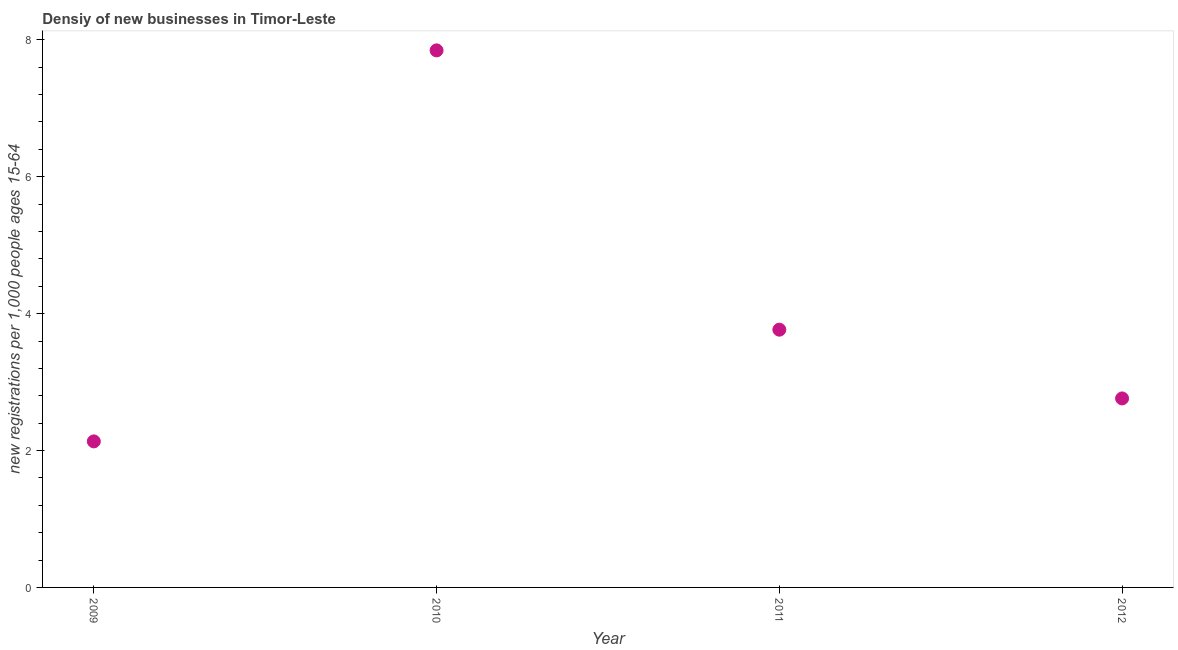What is the density of new business in 2012?
Offer a terse response. 2.76. Across all years, what is the maximum density of new business?
Offer a terse response. 7.85. Across all years, what is the minimum density of new business?
Keep it short and to the point. 2.13. In which year was the density of new business minimum?
Your answer should be very brief. 2009. What is the sum of the density of new business?
Your answer should be compact. 16.51. What is the difference between the density of new business in 2009 and 2012?
Ensure brevity in your answer.  -0.63. What is the average density of new business per year?
Your answer should be compact. 4.13. What is the median density of new business?
Your answer should be compact. 3.26. Do a majority of the years between 2009 and 2011 (inclusive) have density of new business greater than 5.2 ?
Your response must be concise. No. What is the ratio of the density of new business in 2011 to that in 2012?
Provide a short and direct response. 1.36. Is the density of new business in 2009 less than that in 2010?
Provide a succinct answer. Yes. What is the difference between the highest and the second highest density of new business?
Your answer should be compact. 4.08. What is the difference between the highest and the lowest density of new business?
Ensure brevity in your answer.  5.71. In how many years, is the density of new business greater than the average density of new business taken over all years?
Your answer should be very brief. 1. How many dotlines are there?
Your answer should be compact. 1. Are the values on the major ticks of Y-axis written in scientific E-notation?
Your response must be concise. No. Does the graph contain any zero values?
Ensure brevity in your answer.  No. Does the graph contain grids?
Make the answer very short. No. What is the title of the graph?
Ensure brevity in your answer.  Densiy of new businesses in Timor-Leste. What is the label or title of the X-axis?
Make the answer very short. Year. What is the label or title of the Y-axis?
Make the answer very short. New registrations per 1,0 people ages 15-64. What is the new registrations per 1,000 people ages 15-64 in 2009?
Provide a succinct answer. 2.13. What is the new registrations per 1,000 people ages 15-64 in 2010?
Give a very brief answer. 7.85. What is the new registrations per 1,000 people ages 15-64 in 2011?
Give a very brief answer. 3.77. What is the new registrations per 1,000 people ages 15-64 in 2012?
Give a very brief answer. 2.76. What is the difference between the new registrations per 1,000 people ages 15-64 in 2009 and 2010?
Offer a terse response. -5.71. What is the difference between the new registrations per 1,000 people ages 15-64 in 2009 and 2011?
Provide a succinct answer. -1.63. What is the difference between the new registrations per 1,000 people ages 15-64 in 2009 and 2012?
Offer a terse response. -0.63. What is the difference between the new registrations per 1,000 people ages 15-64 in 2010 and 2011?
Provide a short and direct response. 4.08. What is the difference between the new registrations per 1,000 people ages 15-64 in 2010 and 2012?
Make the answer very short. 5.08. What is the difference between the new registrations per 1,000 people ages 15-64 in 2011 and 2012?
Offer a terse response. 1. What is the ratio of the new registrations per 1,000 people ages 15-64 in 2009 to that in 2010?
Provide a succinct answer. 0.27. What is the ratio of the new registrations per 1,000 people ages 15-64 in 2009 to that in 2011?
Offer a very short reply. 0.57. What is the ratio of the new registrations per 1,000 people ages 15-64 in 2009 to that in 2012?
Your answer should be compact. 0.77. What is the ratio of the new registrations per 1,000 people ages 15-64 in 2010 to that in 2011?
Ensure brevity in your answer.  2.08. What is the ratio of the new registrations per 1,000 people ages 15-64 in 2010 to that in 2012?
Offer a very short reply. 2.84. What is the ratio of the new registrations per 1,000 people ages 15-64 in 2011 to that in 2012?
Your response must be concise. 1.36. 